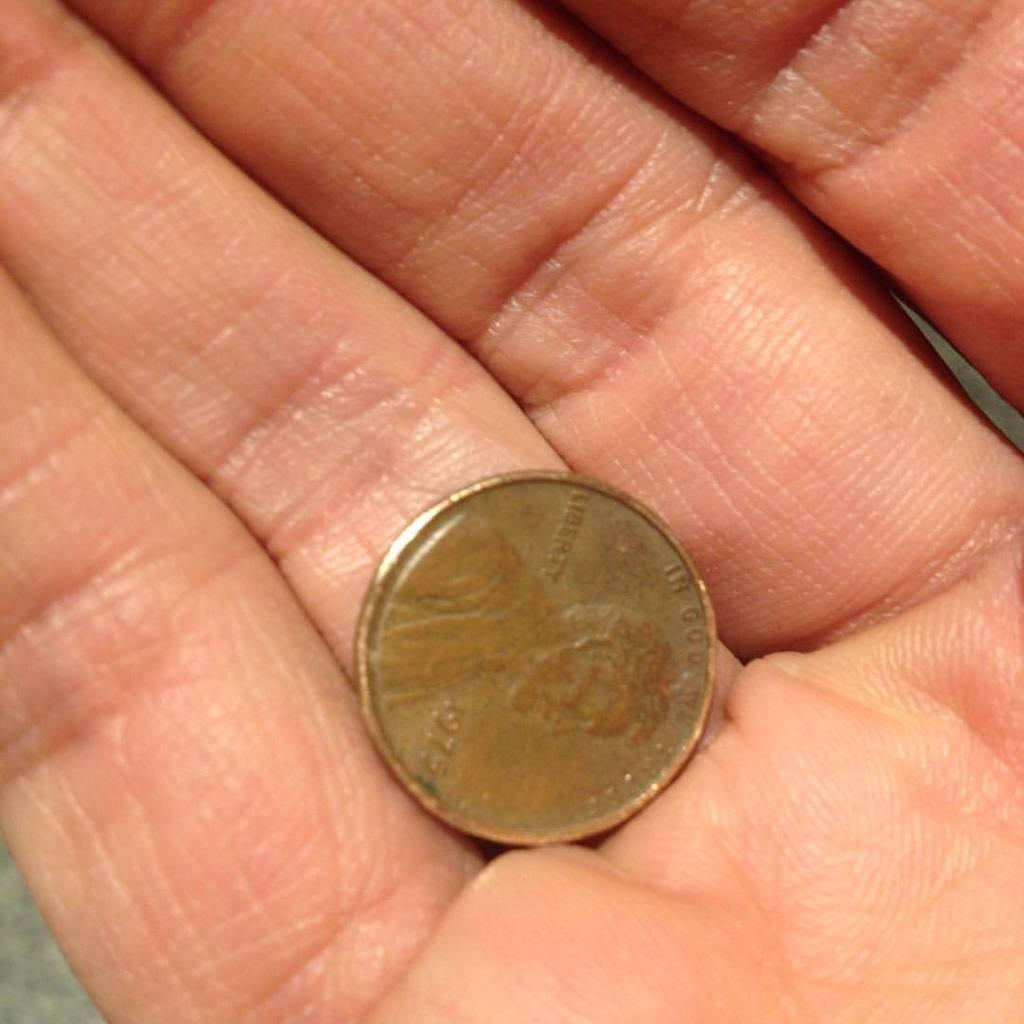What year is this penny?
Your response must be concise. 1975. What is written in the middle of lincoln's back on this penny?
Offer a very short reply. Liberty. 